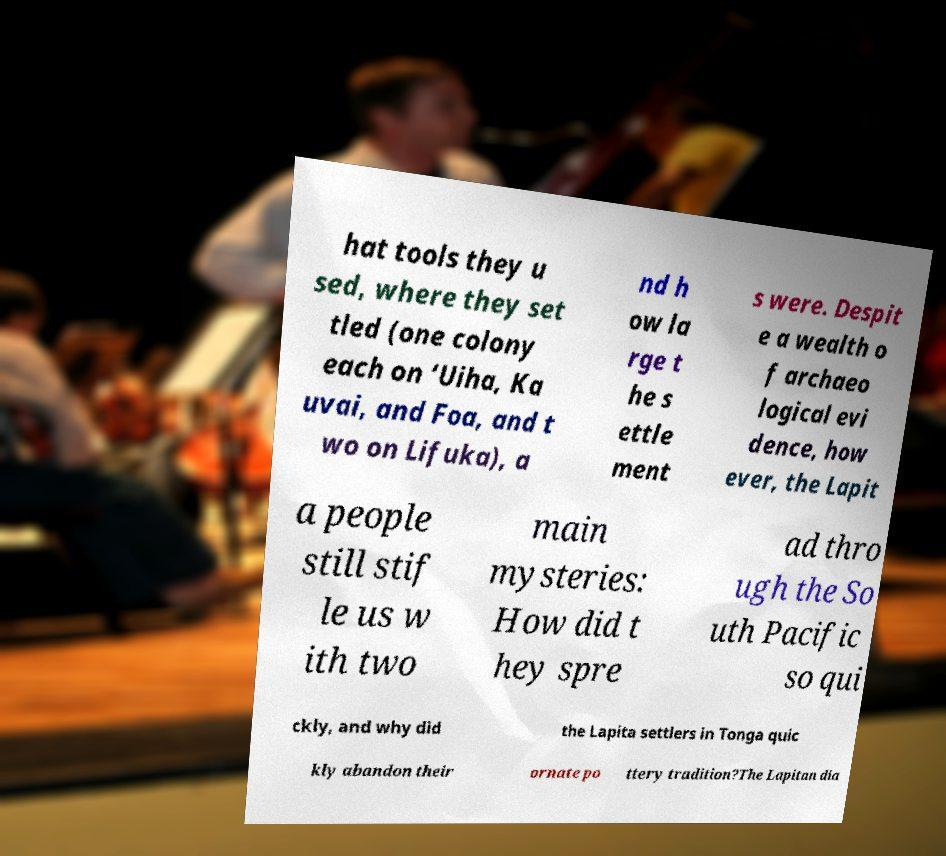For documentation purposes, I need the text within this image transcribed. Could you provide that? hat tools they u sed, where they set tled (one colony each on ‘Uiha, Ka uvai, and Foa, and t wo on Lifuka), a nd h ow la rge t he s ettle ment s were. Despit e a wealth o f archaeo logical evi dence, how ever, the Lapit a people still stif le us w ith two main mysteries: How did t hey spre ad thro ugh the So uth Pacific so qui ckly, and why did the Lapita settlers in Tonga quic kly abandon their ornate po ttery tradition?The Lapitan dia 